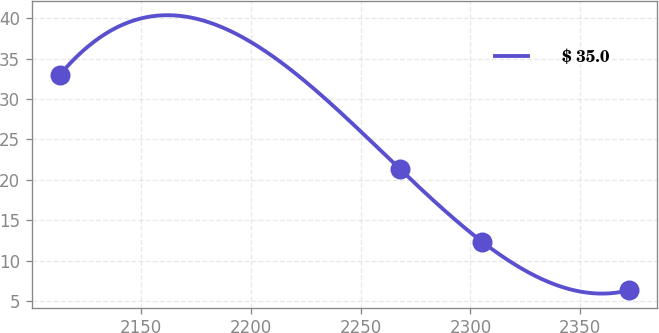<chart> <loc_0><loc_0><loc_500><loc_500><line_chart><ecel><fcel>$ 35.0<nl><fcel>2112.99<fcel>33.02<nl><fcel>2267.7<fcel>21.38<nl><fcel>2305.45<fcel>12.31<nl><fcel>2372.31<fcel>6.33<nl></chart> 